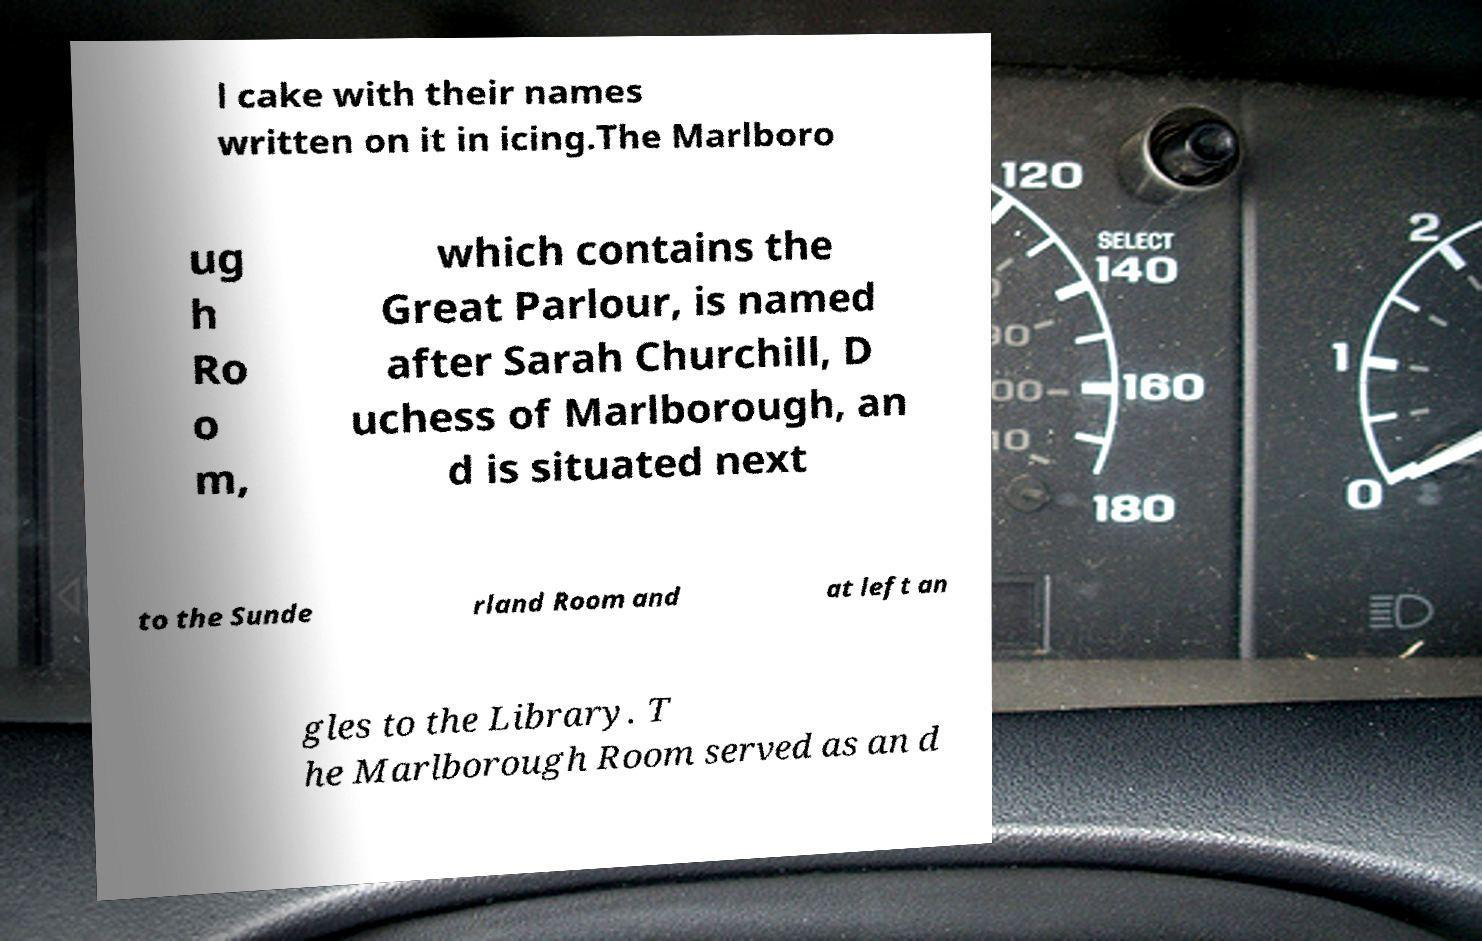Could you assist in decoding the text presented in this image and type it out clearly? l cake with their names written on it in icing.The Marlboro ug h Ro o m, which contains the Great Parlour, is named after Sarah Churchill, D uchess of Marlborough, an d is situated next to the Sunde rland Room and at left an gles to the Library. T he Marlborough Room served as an d 